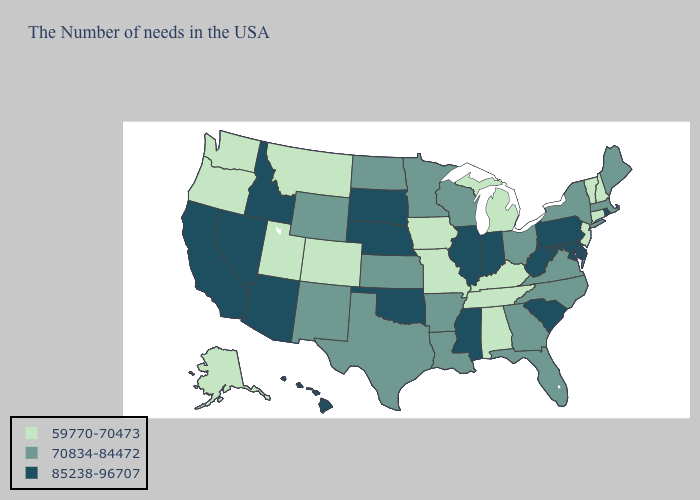What is the value of Oklahoma?
Write a very short answer. 85238-96707. Name the states that have a value in the range 85238-96707?
Keep it brief. Rhode Island, Delaware, Maryland, Pennsylvania, South Carolina, West Virginia, Indiana, Illinois, Mississippi, Nebraska, Oklahoma, South Dakota, Arizona, Idaho, Nevada, California, Hawaii. Which states hav the highest value in the West?
Answer briefly. Arizona, Idaho, Nevada, California, Hawaii. Name the states that have a value in the range 70834-84472?
Quick response, please. Maine, Massachusetts, New York, Virginia, North Carolina, Ohio, Florida, Georgia, Wisconsin, Louisiana, Arkansas, Minnesota, Kansas, Texas, North Dakota, Wyoming, New Mexico. Does the first symbol in the legend represent the smallest category?
Give a very brief answer. Yes. What is the value of Hawaii?
Concise answer only. 85238-96707. Which states have the lowest value in the West?
Keep it brief. Colorado, Utah, Montana, Washington, Oregon, Alaska. Does Alaska have the highest value in the USA?
Concise answer only. No. What is the value of Nebraska?
Answer briefly. 85238-96707. Does the first symbol in the legend represent the smallest category?
Answer briefly. Yes. Name the states that have a value in the range 59770-70473?
Give a very brief answer. New Hampshire, Vermont, Connecticut, New Jersey, Michigan, Kentucky, Alabama, Tennessee, Missouri, Iowa, Colorado, Utah, Montana, Washington, Oregon, Alaska. What is the lowest value in the South?
Give a very brief answer. 59770-70473. Which states have the highest value in the USA?
Quick response, please. Rhode Island, Delaware, Maryland, Pennsylvania, South Carolina, West Virginia, Indiana, Illinois, Mississippi, Nebraska, Oklahoma, South Dakota, Arizona, Idaho, Nevada, California, Hawaii. Does the map have missing data?
Write a very short answer. No. What is the value of Georgia?
Concise answer only. 70834-84472. 